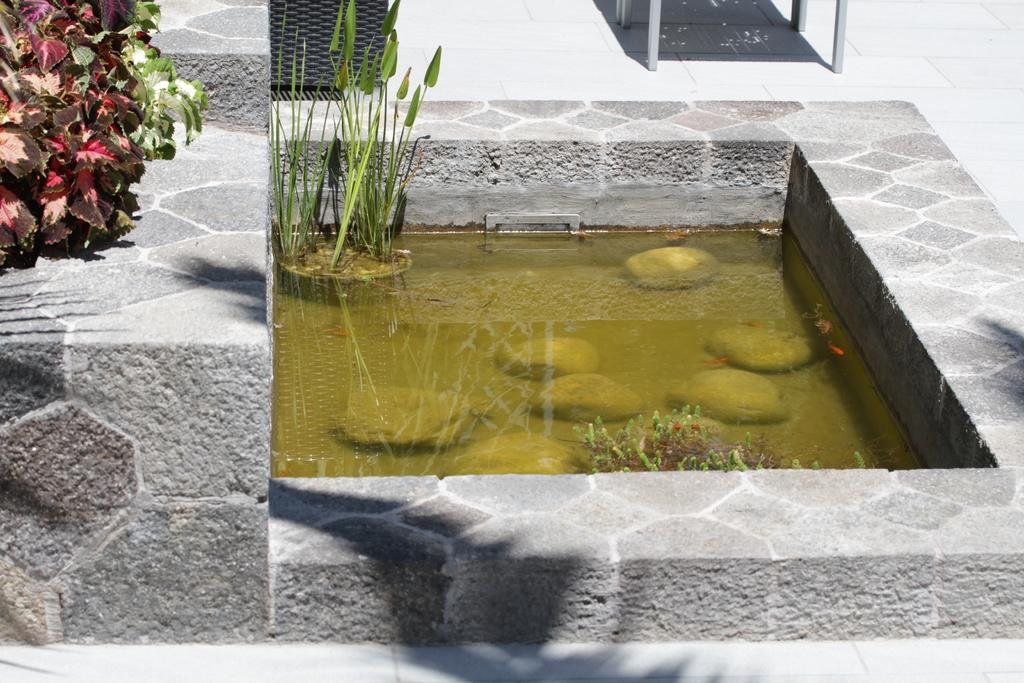What is the primary element visible in the image? There is water in the image. What type of vegetation can be seen in the image? There is grass and plants in the image. Can you describe the object on the floor in the background of the image? Unfortunately, the facts provided do not give enough information to describe the object on the floor in the background. What color is the sweater worn by the person in the image? There is no person wearing a sweater in the image; it only features water, grass, plants, and an unidentified object on the floor in the background. 